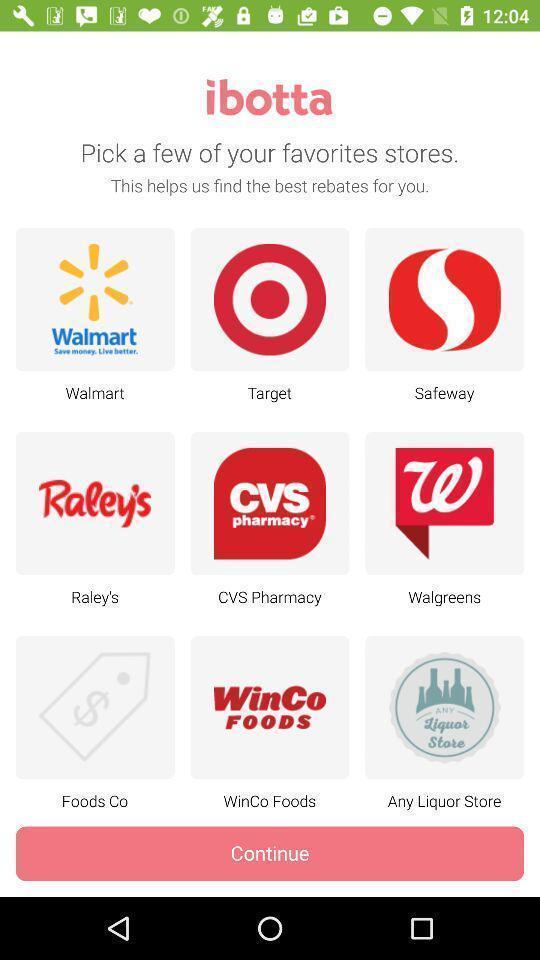Explain the elements present in this screenshot. Screen displaying the various stores. 